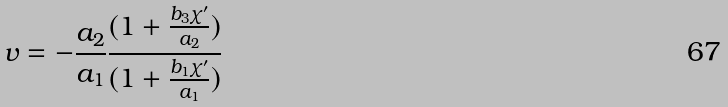Convert formula to latex. <formula><loc_0><loc_0><loc_500><loc_500>v = - \frac { a _ { 2 } } { a _ { 1 } } \frac { ( 1 + \frac { b _ { 3 } \chi ^ { \prime } } { a _ { 2 } } ) } { ( 1 + \frac { b _ { 1 } \chi ^ { \prime } } { a _ { 1 } } ) }</formula> 